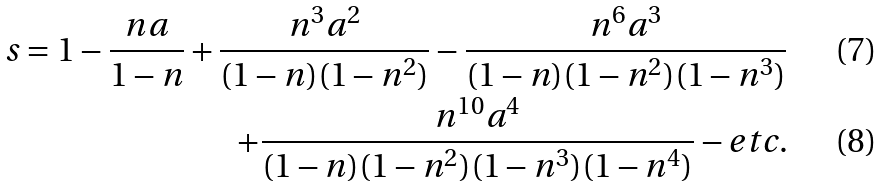Convert formula to latex. <formula><loc_0><loc_0><loc_500><loc_500>s = 1 - \frac { n a } { 1 - n } + \frac { n ^ { 3 } a ^ { 2 } } { ( 1 - n ) ( 1 - n ^ { 2 } ) } - \frac { n ^ { 6 } a ^ { 3 } } { ( 1 - n ) ( 1 - n ^ { 2 } ) ( 1 - n ^ { 3 } ) } \\ + \frac { n ^ { 1 0 } a ^ { 4 } } { ( 1 - n ) ( 1 - n ^ { 2 } ) ( 1 - n ^ { 3 } ) ( 1 - n ^ { 4 } ) } - e t c .</formula> 